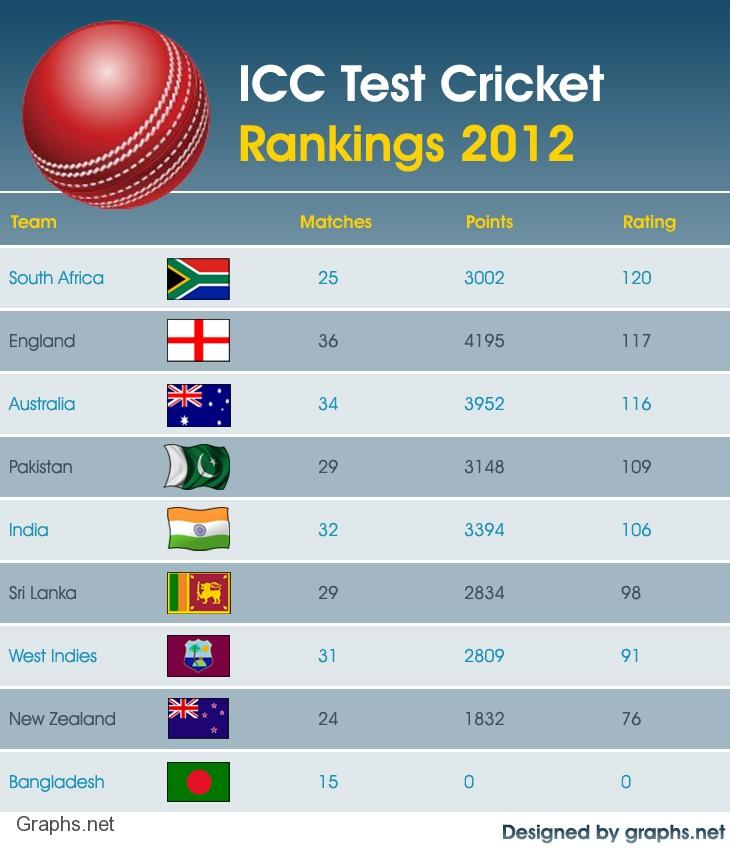Identify some key points in this picture. In the year 2012, England played the highest number of test matches among all teams. In 2012, India played a total of 32 test cricket matches. In 2012, England played a total of 36 test cricket matches. In 2012, New Zealand had the second-lowest ICC test cricket rating among all cricket teams. In 2012, the cricket team with the highest ICC test cricket rating was South Africa. 